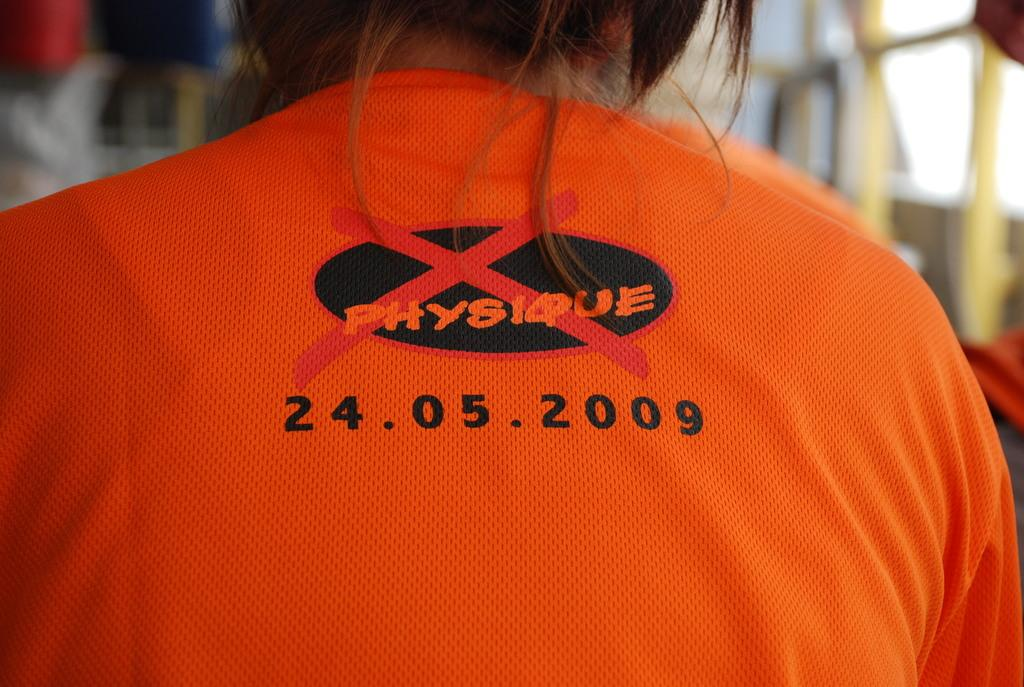<image>
Give a short and clear explanation of the subsequent image. A person has the date 24.05.2009 on the back of their orange shirt. 